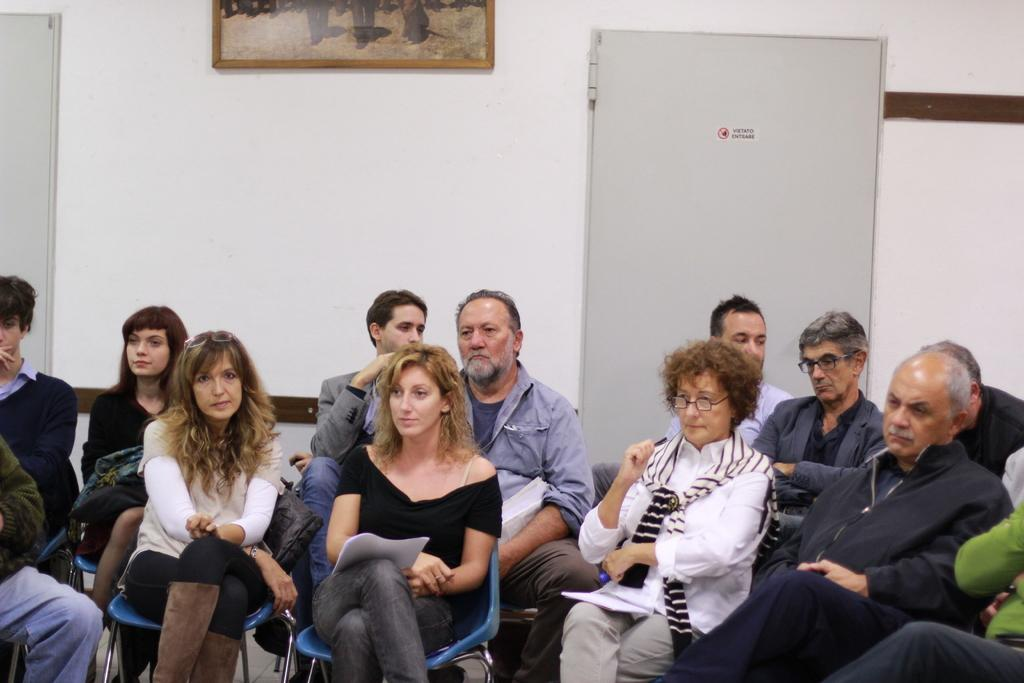What are the people in the image doing? The people in the image are sitting in chairs. What can be seen on the wall in the image? There is a photo frame on the wall in the image. What is located beside the photo frame in the image? There is a closed door beside the photo frame in the image. How many cows are visible in the image? There are no cows present in the image. What type of veil is being worn by the people in the image? There is no veil present in the image; the people are simply sitting in chairs. 